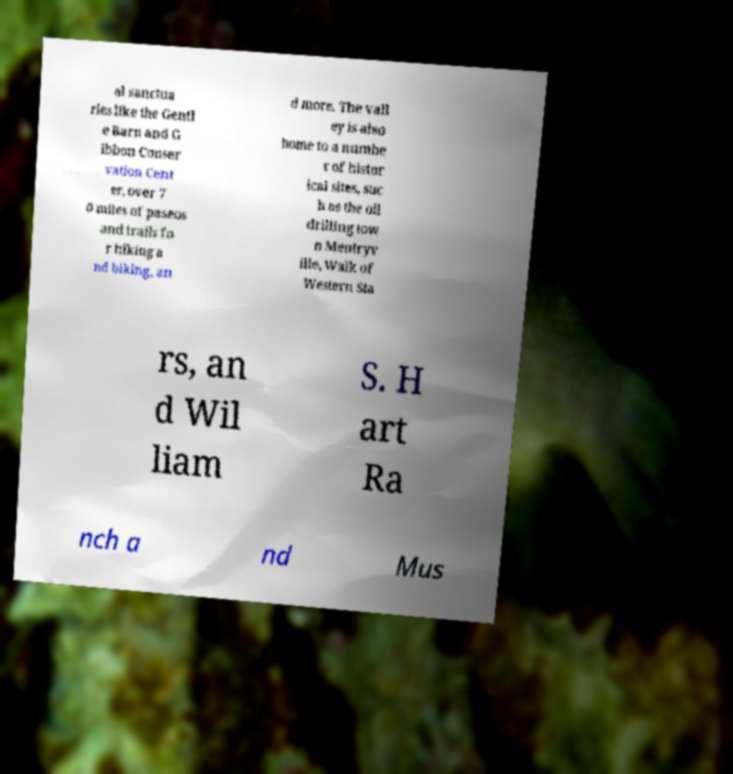Can you accurately transcribe the text from the provided image for me? al sanctua ries like the Gentl e Barn and G ibbon Conser vation Cent er, over 7 0 miles of paseos and trails fo r hiking a nd biking, an d more. The vall ey is also home to a numbe r of histor ical sites, suc h as the oil drilling tow n Mentryv ille, Walk of Western Sta rs, an d Wil liam S. H art Ra nch a nd Mus 